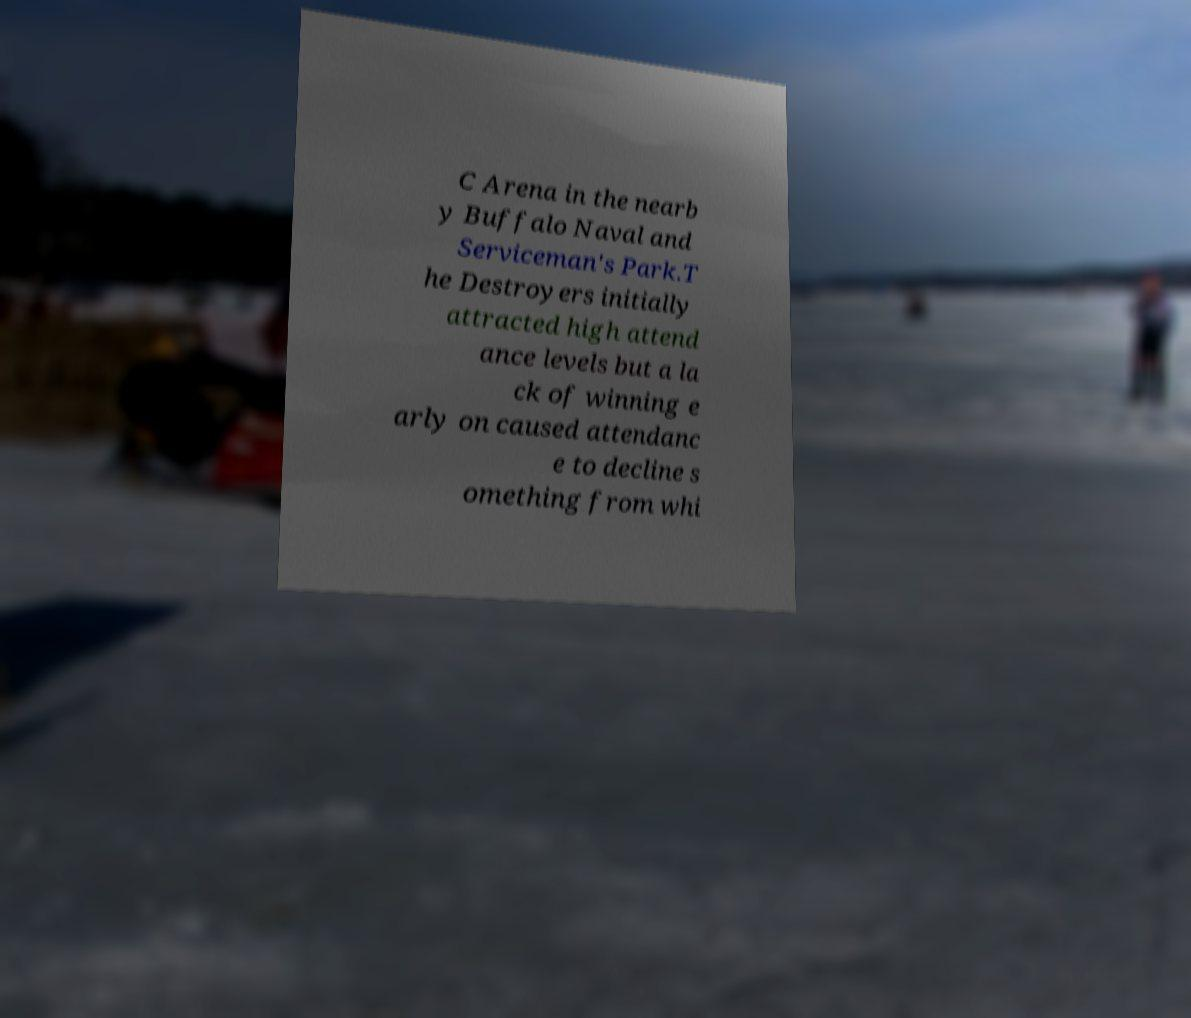Can you read and provide the text displayed in the image?This photo seems to have some interesting text. Can you extract and type it out for me? C Arena in the nearb y Buffalo Naval and Serviceman's Park.T he Destroyers initially attracted high attend ance levels but a la ck of winning e arly on caused attendanc e to decline s omething from whi 